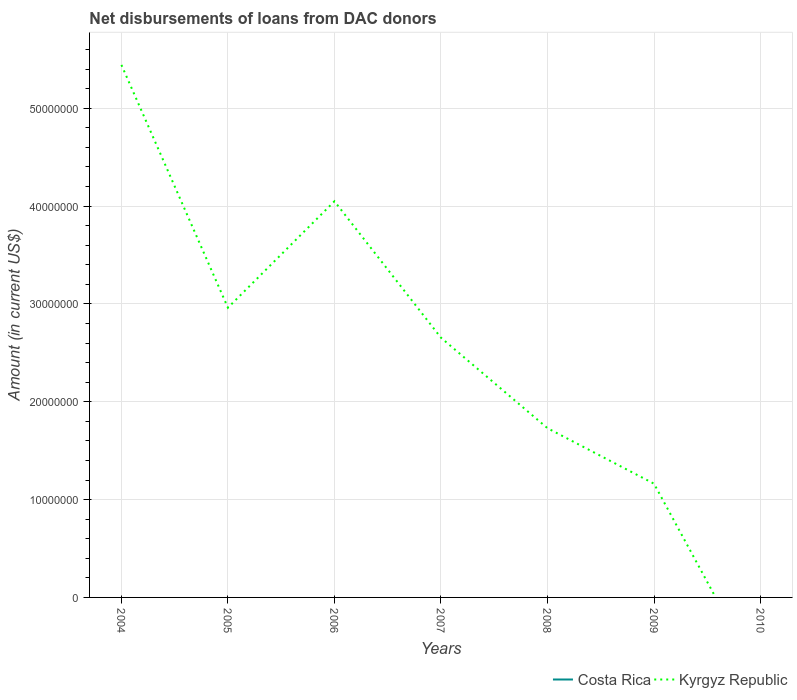How many different coloured lines are there?
Your answer should be compact. 1. Is the number of lines equal to the number of legend labels?
Provide a succinct answer. No. Across all years, what is the maximum amount of loans disbursed in Kyrgyz Republic?
Provide a succinct answer. 0. What is the total amount of loans disbursed in Kyrgyz Republic in the graph?
Offer a terse response. 2.79e+07. What is the difference between the highest and the second highest amount of loans disbursed in Kyrgyz Republic?
Offer a very short reply. 5.44e+07. What is the difference between the highest and the lowest amount of loans disbursed in Kyrgyz Republic?
Make the answer very short. 4. How many years are there in the graph?
Ensure brevity in your answer.  7. Are the values on the major ticks of Y-axis written in scientific E-notation?
Your answer should be compact. No. Does the graph contain any zero values?
Provide a short and direct response. Yes. How are the legend labels stacked?
Your response must be concise. Horizontal. What is the title of the graph?
Your response must be concise. Net disbursements of loans from DAC donors. What is the label or title of the X-axis?
Provide a short and direct response. Years. What is the label or title of the Y-axis?
Your response must be concise. Amount (in current US$). What is the Amount (in current US$) of Kyrgyz Republic in 2004?
Your answer should be very brief. 5.44e+07. What is the Amount (in current US$) in Kyrgyz Republic in 2005?
Your answer should be compact. 2.96e+07. What is the Amount (in current US$) of Kyrgyz Republic in 2006?
Ensure brevity in your answer.  4.05e+07. What is the Amount (in current US$) of Kyrgyz Republic in 2007?
Keep it short and to the point. 2.65e+07. What is the Amount (in current US$) of Costa Rica in 2008?
Your answer should be compact. 0. What is the Amount (in current US$) of Kyrgyz Republic in 2008?
Your response must be concise. 1.73e+07. What is the Amount (in current US$) of Costa Rica in 2009?
Your answer should be compact. 0. What is the Amount (in current US$) in Kyrgyz Republic in 2009?
Provide a short and direct response. 1.16e+07. Across all years, what is the maximum Amount (in current US$) in Kyrgyz Republic?
Provide a short and direct response. 5.44e+07. Across all years, what is the minimum Amount (in current US$) in Kyrgyz Republic?
Give a very brief answer. 0. What is the total Amount (in current US$) in Kyrgyz Republic in the graph?
Give a very brief answer. 1.80e+08. What is the difference between the Amount (in current US$) of Kyrgyz Republic in 2004 and that in 2005?
Offer a very short reply. 2.48e+07. What is the difference between the Amount (in current US$) of Kyrgyz Republic in 2004 and that in 2006?
Your response must be concise. 1.39e+07. What is the difference between the Amount (in current US$) of Kyrgyz Republic in 2004 and that in 2007?
Offer a very short reply. 2.79e+07. What is the difference between the Amount (in current US$) in Kyrgyz Republic in 2004 and that in 2008?
Make the answer very short. 3.71e+07. What is the difference between the Amount (in current US$) of Kyrgyz Republic in 2004 and that in 2009?
Ensure brevity in your answer.  4.28e+07. What is the difference between the Amount (in current US$) of Kyrgyz Republic in 2005 and that in 2006?
Ensure brevity in your answer.  -1.09e+07. What is the difference between the Amount (in current US$) in Kyrgyz Republic in 2005 and that in 2007?
Offer a very short reply. 3.07e+06. What is the difference between the Amount (in current US$) in Kyrgyz Republic in 2005 and that in 2008?
Offer a terse response. 1.23e+07. What is the difference between the Amount (in current US$) of Kyrgyz Republic in 2005 and that in 2009?
Provide a short and direct response. 1.80e+07. What is the difference between the Amount (in current US$) in Kyrgyz Republic in 2006 and that in 2007?
Keep it short and to the point. 1.39e+07. What is the difference between the Amount (in current US$) in Kyrgyz Republic in 2006 and that in 2008?
Offer a very short reply. 2.32e+07. What is the difference between the Amount (in current US$) in Kyrgyz Republic in 2006 and that in 2009?
Offer a very short reply. 2.89e+07. What is the difference between the Amount (in current US$) in Kyrgyz Republic in 2007 and that in 2008?
Provide a short and direct response. 9.25e+06. What is the difference between the Amount (in current US$) of Kyrgyz Republic in 2007 and that in 2009?
Give a very brief answer. 1.49e+07. What is the difference between the Amount (in current US$) in Kyrgyz Republic in 2008 and that in 2009?
Your response must be concise. 5.67e+06. What is the average Amount (in current US$) of Kyrgyz Republic per year?
Provide a succinct answer. 2.57e+07. What is the ratio of the Amount (in current US$) of Kyrgyz Republic in 2004 to that in 2005?
Ensure brevity in your answer.  1.84. What is the ratio of the Amount (in current US$) in Kyrgyz Republic in 2004 to that in 2006?
Give a very brief answer. 1.34. What is the ratio of the Amount (in current US$) of Kyrgyz Republic in 2004 to that in 2007?
Ensure brevity in your answer.  2.05. What is the ratio of the Amount (in current US$) of Kyrgyz Republic in 2004 to that in 2008?
Your answer should be very brief. 3.15. What is the ratio of the Amount (in current US$) of Kyrgyz Republic in 2004 to that in 2009?
Give a very brief answer. 4.68. What is the ratio of the Amount (in current US$) in Kyrgyz Republic in 2005 to that in 2006?
Give a very brief answer. 0.73. What is the ratio of the Amount (in current US$) of Kyrgyz Republic in 2005 to that in 2007?
Offer a terse response. 1.12. What is the ratio of the Amount (in current US$) of Kyrgyz Republic in 2005 to that in 2008?
Offer a very short reply. 1.71. What is the ratio of the Amount (in current US$) of Kyrgyz Republic in 2005 to that in 2009?
Provide a short and direct response. 2.55. What is the ratio of the Amount (in current US$) of Kyrgyz Republic in 2006 to that in 2007?
Offer a terse response. 1.53. What is the ratio of the Amount (in current US$) in Kyrgyz Republic in 2006 to that in 2008?
Provide a short and direct response. 2.34. What is the ratio of the Amount (in current US$) of Kyrgyz Republic in 2006 to that in 2009?
Your answer should be very brief. 3.48. What is the ratio of the Amount (in current US$) in Kyrgyz Republic in 2007 to that in 2008?
Make the answer very short. 1.53. What is the ratio of the Amount (in current US$) of Kyrgyz Republic in 2007 to that in 2009?
Provide a short and direct response. 2.28. What is the ratio of the Amount (in current US$) in Kyrgyz Republic in 2008 to that in 2009?
Your answer should be compact. 1.49. What is the difference between the highest and the second highest Amount (in current US$) in Kyrgyz Republic?
Offer a very short reply. 1.39e+07. What is the difference between the highest and the lowest Amount (in current US$) of Kyrgyz Republic?
Keep it short and to the point. 5.44e+07. 